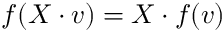<formula> <loc_0><loc_0><loc_500><loc_500>f ( X \cdot v ) = X \cdot f ( v )</formula> 